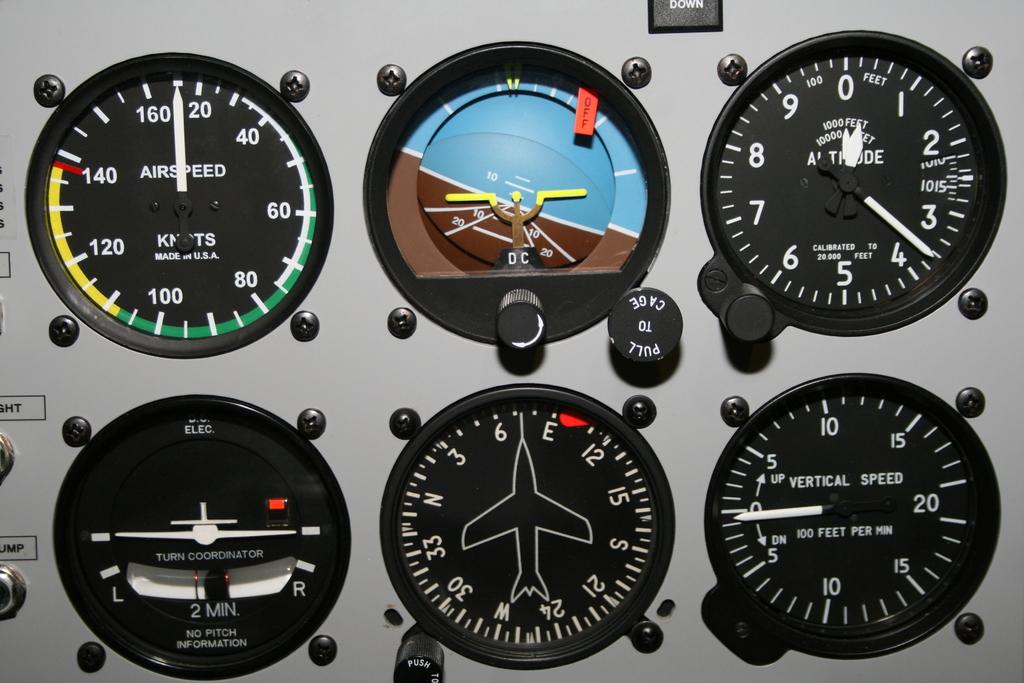What number is the altitude gauge approaching?
Ensure brevity in your answer.  4. 